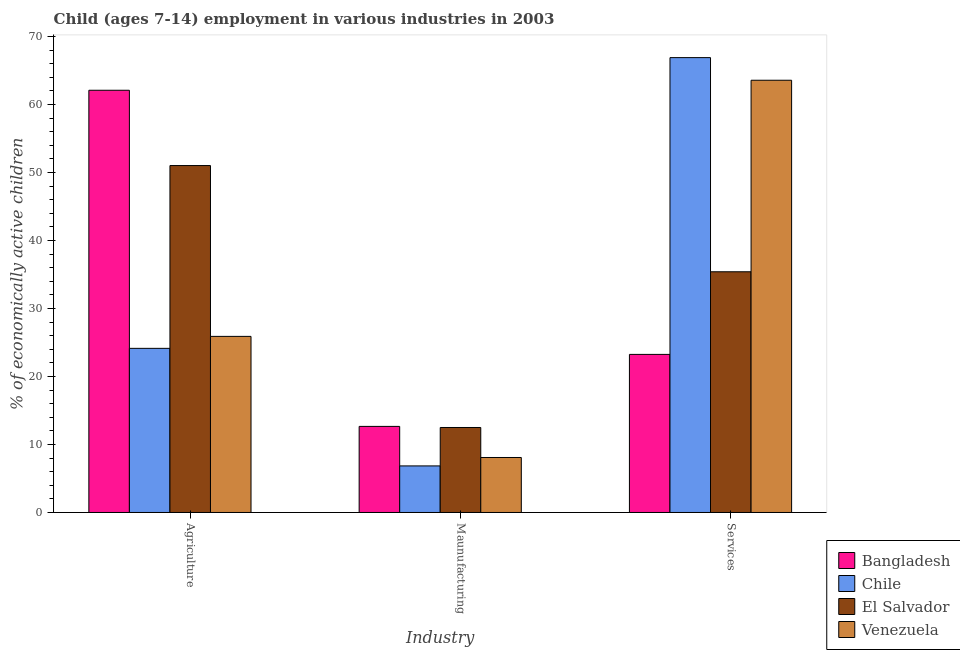How many different coloured bars are there?
Provide a succinct answer. 4. How many groups of bars are there?
Offer a very short reply. 3. Are the number of bars per tick equal to the number of legend labels?
Offer a very short reply. Yes. Are the number of bars on each tick of the X-axis equal?
Your response must be concise. Yes. How many bars are there on the 1st tick from the left?
Offer a terse response. 4. What is the label of the 2nd group of bars from the left?
Offer a very short reply. Maunufacturing. What is the percentage of economically active children in services in Bangladesh?
Ensure brevity in your answer.  23.25. Across all countries, what is the maximum percentage of economically active children in services?
Keep it short and to the point. 66.9. Across all countries, what is the minimum percentage of economically active children in manufacturing?
Provide a succinct answer. 6.85. In which country was the percentage of economically active children in agriculture minimum?
Give a very brief answer. Chile. What is the total percentage of economically active children in agriculture in the graph?
Give a very brief answer. 163.17. What is the difference between the percentage of economically active children in agriculture in El Salvador and that in Chile?
Give a very brief answer. 26.89. What is the difference between the percentage of economically active children in agriculture in El Salvador and the percentage of economically active children in manufacturing in Venezuela?
Your answer should be compact. 42.94. What is the average percentage of economically active children in services per country?
Make the answer very short. 47.28. What is the difference between the percentage of economically active children in services and percentage of economically active children in agriculture in El Salvador?
Ensure brevity in your answer.  -15.62. What is the ratio of the percentage of economically active children in manufacturing in Chile to that in Bangladesh?
Make the answer very short. 0.54. Is the difference between the percentage of economically active children in agriculture in El Salvador and Venezuela greater than the difference between the percentage of economically active children in manufacturing in El Salvador and Venezuela?
Provide a succinct answer. Yes. What is the difference between the highest and the second highest percentage of economically active children in services?
Your answer should be very brief. 3.33. What is the difference between the highest and the lowest percentage of economically active children in agriculture?
Provide a short and direct response. 37.96. What does the 4th bar from the left in Maunufacturing represents?
Provide a succinct answer. Venezuela. What does the 4th bar from the right in Maunufacturing represents?
Offer a very short reply. Bangladesh. Is it the case that in every country, the sum of the percentage of economically active children in agriculture and percentage of economically active children in manufacturing is greater than the percentage of economically active children in services?
Your answer should be compact. No. Are all the bars in the graph horizontal?
Give a very brief answer. No. How many countries are there in the graph?
Offer a very short reply. 4. What is the difference between two consecutive major ticks on the Y-axis?
Offer a terse response. 10. Are the values on the major ticks of Y-axis written in scientific E-notation?
Offer a terse response. No. Does the graph contain any zero values?
Provide a succinct answer. No. Does the graph contain grids?
Make the answer very short. No. How many legend labels are there?
Make the answer very short. 4. What is the title of the graph?
Provide a succinct answer. Child (ages 7-14) employment in various industries in 2003. What is the label or title of the X-axis?
Your response must be concise. Industry. What is the label or title of the Y-axis?
Provide a succinct answer. % of economically active children. What is the % of economically active children in Bangladesh in Agriculture?
Give a very brief answer. 62.1. What is the % of economically active children of Chile in Agriculture?
Offer a terse response. 24.14. What is the % of economically active children of El Salvador in Agriculture?
Keep it short and to the point. 51.03. What is the % of economically active children of Venezuela in Agriculture?
Provide a short and direct response. 25.9. What is the % of economically active children of Bangladesh in Maunufacturing?
Your answer should be very brief. 12.66. What is the % of economically active children of Chile in Maunufacturing?
Keep it short and to the point. 6.85. What is the % of economically active children in El Salvador in Maunufacturing?
Your answer should be compact. 12.5. What is the % of economically active children of Venezuela in Maunufacturing?
Your answer should be compact. 8.09. What is the % of economically active children of Bangladesh in Services?
Your response must be concise. 23.25. What is the % of economically active children in Chile in Services?
Ensure brevity in your answer.  66.9. What is the % of economically active children of El Salvador in Services?
Your answer should be compact. 35.4. What is the % of economically active children of Venezuela in Services?
Offer a terse response. 63.57. Across all Industry, what is the maximum % of economically active children of Bangladesh?
Your answer should be very brief. 62.1. Across all Industry, what is the maximum % of economically active children of Chile?
Make the answer very short. 66.9. Across all Industry, what is the maximum % of economically active children of El Salvador?
Offer a terse response. 51.03. Across all Industry, what is the maximum % of economically active children in Venezuela?
Your answer should be very brief. 63.57. Across all Industry, what is the minimum % of economically active children in Bangladesh?
Keep it short and to the point. 12.66. Across all Industry, what is the minimum % of economically active children in Chile?
Your answer should be compact. 6.85. Across all Industry, what is the minimum % of economically active children of El Salvador?
Provide a succinct answer. 12.5. Across all Industry, what is the minimum % of economically active children in Venezuela?
Ensure brevity in your answer.  8.09. What is the total % of economically active children in Bangladesh in the graph?
Provide a succinct answer. 98.01. What is the total % of economically active children in Chile in the graph?
Your answer should be compact. 97.89. What is the total % of economically active children in El Salvador in the graph?
Provide a succinct answer. 98.93. What is the total % of economically active children in Venezuela in the graph?
Ensure brevity in your answer.  97.56. What is the difference between the % of economically active children in Bangladesh in Agriculture and that in Maunufacturing?
Ensure brevity in your answer.  49.44. What is the difference between the % of economically active children of Chile in Agriculture and that in Maunufacturing?
Keep it short and to the point. 17.29. What is the difference between the % of economically active children of El Salvador in Agriculture and that in Maunufacturing?
Offer a terse response. 38.53. What is the difference between the % of economically active children of Venezuela in Agriculture and that in Maunufacturing?
Offer a terse response. 17.81. What is the difference between the % of economically active children in Bangladesh in Agriculture and that in Services?
Make the answer very short. 38.85. What is the difference between the % of economically active children of Chile in Agriculture and that in Services?
Provide a short and direct response. -42.76. What is the difference between the % of economically active children of El Salvador in Agriculture and that in Services?
Offer a very short reply. 15.62. What is the difference between the % of economically active children in Venezuela in Agriculture and that in Services?
Your response must be concise. -37.67. What is the difference between the % of economically active children in Bangladesh in Maunufacturing and that in Services?
Your answer should be compact. -10.59. What is the difference between the % of economically active children of Chile in Maunufacturing and that in Services?
Give a very brief answer. -60.05. What is the difference between the % of economically active children in El Salvador in Maunufacturing and that in Services?
Make the answer very short. -22.9. What is the difference between the % of economically active children in Venezuela in Maunufacturing and that in Services?
Offer a terse response. -55.49. What is the difference between the % of economically active children in Bangladesh in Agriculture and the % of economically active children in Chile in Maunufacturing?
Keep it short and to the point. 55.25. What is the difference between the % of economically active children of Bangladesh in Agriculture and the % of economically active children of El Salvador in Maunufacturing?
Your answer should be compact. 49.6. What is the difference between the % of economically active children of Bangladesh in Agriculture and the % of economically active children of Venezuela in Maunufacturing?
Your answer should be compact. 54.01. What is the difference between the % of economically active children of Chile in Agriculture and the % of economically active children of El Salvador in Maunufacturing?
Ensure brevity in your answer.  11.64. What is the difference between the % of economically active children of Chile in Agriculture and the % of economically active children of Venezuela in Maunufacturing?
Provide a short and direct response. 16.05. What is the difference between the % of economically active children in El Salvador in Agriculture and the % of economically active children in Venezuela in Maunufacturing?
Your answer should be very brief. 42.94. What is the difference between the % of economically active children in Bangladesh in Agriculture and the % of economically active children in Chile in Services?
Provide a short and direct response. -4.8. What is the difference between the % of economically active children of Bangladesh in Agriculture and the % of economically active children of El Salvador in Services?
Provide a succinct answer. 26.7. What is the difference between the % of economically active children in Bangladesh in Agriculture and the % of economically active children in Venezuela in Services?
Keep it short and to the point. -1.47. What is the difference between the % of economically active children of Chile in Agriculture and the % of economically active children of El Salvador in Services?
Offer a terse response. -11.26. What is the difference between the % of economically active children of Chile in Agriculture and the % of economically active children of Venezuela in Services?
Keep it short and to the point. -39.43. What is the difference between the % of economically active children in El Salvador in Agriculture and the % of economically active children in Venezuela in Services?
Keep it short and to the point. -12.55. What is the difference between the % of economically active children of Bangladesh in Maunufacturing and the % of economically active children of Chile in Services?
Your response must be concise. -54.24. What is the difference between the % of economically active children of Bangladesh in Maunufacturing and the % of economically active children of El Salvador in Services?
Provide a short and direct response. -22.74. What is the difference between the % of economically active children in Bangladesh in Maunufacturing and the % of economically active children in Venezuela in Services?
Offer a very short reply. -50.91. What is the difference between the % of economically active children in Chile in Maunufacturing and the % of economically active children in El Salvador in Services?
Your response must be concise. -28.55. What is the difference between the % of economically active children in Chile in Maunufacturing and the % of economically active children in Venezuela in Services?
Your answer should be compact. -56.72. What is the difference between the % of economically active children in El Salvador in Maunufacturing and the % of economically active children in Venezuela in Services?
Give a very brief answer. -51.07. What is the average % of economically active children of Bangladesh per Industry?
Your response must be concise. 32.67. What is the average % of economically active children in Chile per Industry?
Offer a terse response. 32.63. What is the average % of economically active children of El Salvador per Industry?
Your response must be concise. 32.98. What is the average % of economically active children of Venezuela per Industry?
Keep it short and to the point. 32.52. What is the difference between the % of economically active children in Bangladesh and % of economically active children in Chile in Agriculture?
Provide a succinct answer. 37.96. What is the difference between the % of economically active children of Bangladesh and % of economically active children of El Salvador in Agriculture?
Make the answer very short. 11.07. What is the difference between the % of economically active children of Bangladesh and % of economically active children of Venezuela in Agriculture?
Provide a succinct answer. 36.2. What is the difference between the % of economically active children in Chile and % of economically active children in El Salvador in Agriculture?
Ensure brevity in your answer.  -26.89. What is the difference between the % of economically active children of Chile and % of economically active children of Venezuela in Agriculture?
Your answer should be compact. -1.76. What is the difference between the % of economically active children of El Salvador and % of economically active children of Venezuela in Agriculture?
Give a very brief answer. 25.13. What is the difference between the % of economically active children of Bangladesh and % of economically active children of Chile in Maunufacturing?
Provide a succinct answer. 5.81. What is the difference between the % of economically active children of Bangladesh and % of economically active children of El Salvador in Maunufacturing?
Offer a terse response. 0.16. What is the difference between the % of economically active children in Bangladesh and % of economically active children in Venezuela in Maunufacturing?
Give a very brief answer. 4.57. What is the difference between the % of economically active children in Chile and % of economically active children in El Salvador in Maunufacturing?
Your answer should be very brief. -5.65. What is the difference between the % of economically active children in Chile and % of economically active children in Venezuela in Maunufacturing?
Offer a terse response. -1.24. What is the difference between the % of economically active children in El Salvador and % of economically active children in Venezuela in Maunufacturing?
Offer a terse response. 4.41. What is the difference between the % of economically active children of Bangladesh and % of economically active children of Chile in Services?
Offer a terse response. -43.65. What is the difference between the % of economically active children in Bangladesh and % of economically active children in El Salvador in Services?
Offer a very short reply. -12.15. What is the difference between the % of economically active children in Bangladesh and % of economically active children in Venezuela in Services?
Give a very brief answer. -40.32. What is the difference between the % of economically active children in Chile and % of economically active children in El Salvador in Services?
Your response must be concise. 31.5. What is the difference between the % of economically active children of Chile and % of economically active children of Venezuela in Services?
Provide a short and direct response. 3.33. What is the difference between the % of economically active children of El Salvador and % of economically active children of Venezuela in Services?
Your answer should be compact. -28.17. What is the ratio of the % of economically active children of Bangladesh in Agriculture to that in Maunufacturing?
Offer a terse response. 4.91. What is the ratio of the % of economically active children in Chile in Agriculture to that in Maunufacturing?
Make the answer very short. 3.52. What is the ratio of the % of economically active children of El Salvador in Agriculture to that in Maunufacturing?
Your answer should be compact. 4.08. What is the ratio of the % of economically active children in Venezuela in Agriculture to that in Maunufacturing?
Provide a short and direct response. 3.2. What is the ratio of the % of economically active children in Bangladesh in Agriculture to that in Services?
Give a very brief answer. 2.67. What is the ratio of the % of economically active children of Chile in Agriculture to that in Services?
Your answer should be very brief. 0.36. What is the ratio of the % of economically active children in El Salvador in Agriculture to that in Services?
Provide a succinct answer. 1.44. What is the ratio of the % of economically active children in Venezuela in Agriculture to that in Services?
Offer a terse response. 0.41. What is the ratio of the % of economically active children of Bangladesh in Maunufacturing to that in Services?
Offer a terse response. 0.54. What is the ratio of the % of economically active children in Chile in Maunufacturing to that in Services?
Your response must be concise. 0.1. What is the ratio of the % of economically active children of El Salvador in Maunufacturing to that in Services?
Make the answer very short. 0.35. What is the ratio of the % of economically active children in Venezuela in Maunufacturing to that in Services?
Offer a very short reply. 0.13. What is the difference between the highest and the second highest % of economically active children in Bangladesh?
Offer a terse response. 38.85. What is the difference between the highest and the second highest % of economically active children in Chile?
Your response must be concise. 42.76. What is the difference between the highest and the second highest % of economically active children in El Salvador?
Your response must be concise. 15.62. What is the difference between the highest and the second highest % of economically active children of Venezuela?
Your response must be concise. 37.67. What is the difference between the highest and the lowest % of economically active children of Bangladesh?
Give a very brief answer. 49.44. What is the difference between the highest and the lowest % of economically active children in Chile?
Provide a succinct answer. 60.05. What is the difference between the highest and the lowest % of economically active children in El Salvador?
Keep it short and to the point. 38.53. What is the difference between the highest and the lowest % of economically active children in Venezuela?
Provide a short and direct response. 55.49. 